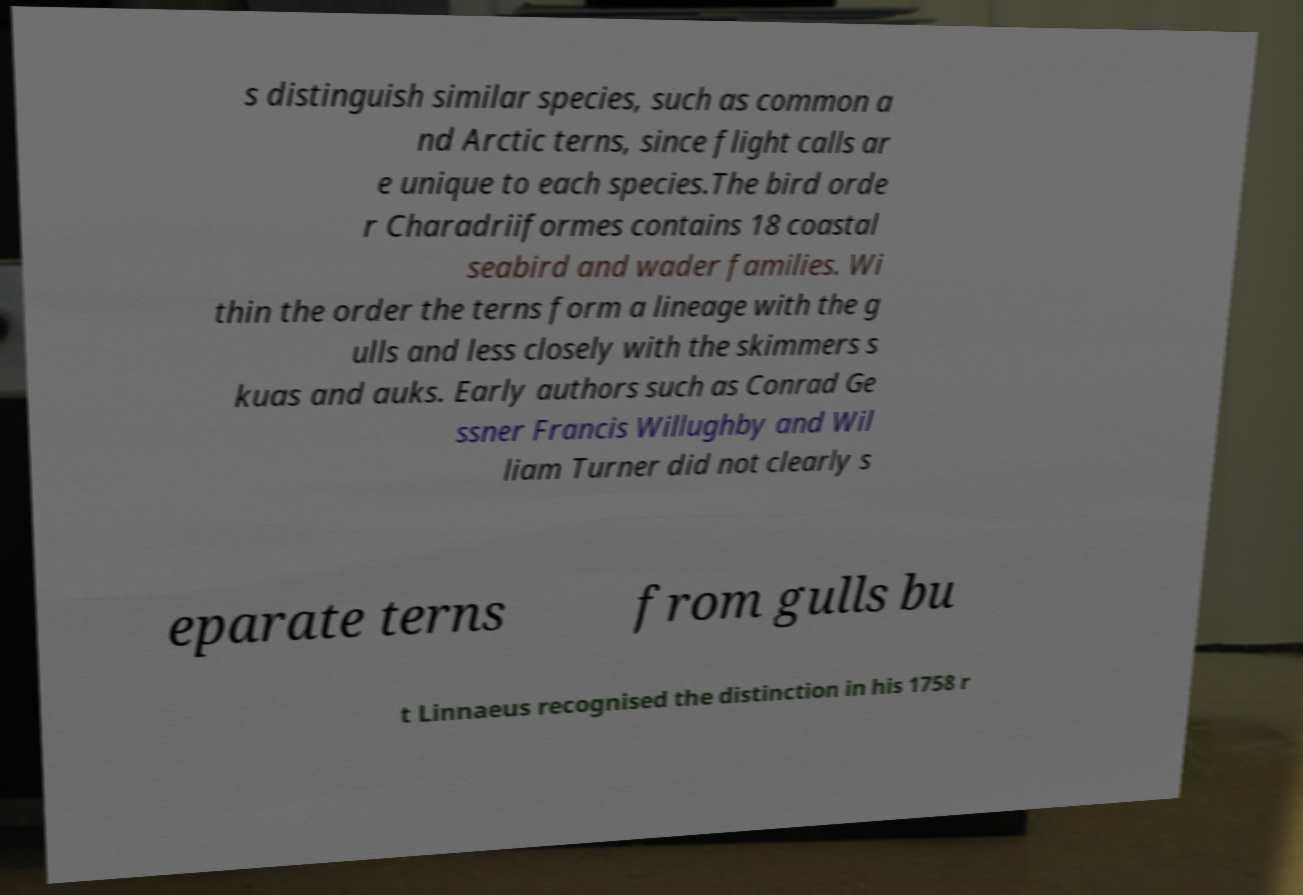Could you extract and type out the text from this image? s distinguish similar species, such as common a nd Arctic terns, since flight calls ar e unique to each species.The bird orde r Charadriiformes contains 18 coastal seabird and wader families. Wi thin the order the terns form a lineage with the g ulls and less closely with the skimmers s kuas and auks. Early authors such as Conrad Ge ssner Francis Willughby and Wil liam Turner did not clearly s eparate terns from gulls bu t Linnaeus recognised the distinction in his 1758 r 